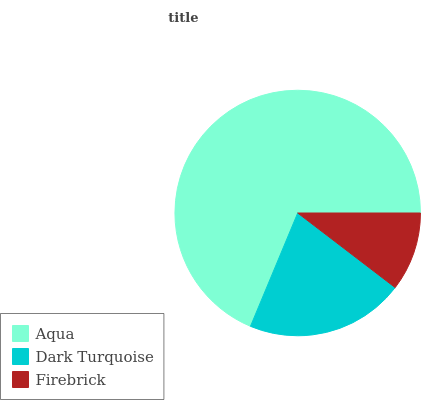Is Firebrick the minimum?
Answer yes or no. Yes. Is Aqua the maximum?
Answer yes or no. Yes. Is Dark Turquoise the minimum?
Answer yes or no. No. Is Dark Turquoise the maximum?
Answer yes or no. No. Is Aqua greater than Dark Turquoise?
Answer yes or no. Yes. Is Dark Turquoise less than Aqua?
Answer yes or no. Yes. Is Dark Turquoise greater than Aqua?
Answer yes or no. No. Is Aqua less than Dark Turquoise?
Answer yes or no. No. Is Dark Turquoise the high median?
Answer yes or no. Yes. Is Dark Turquoise the low median?
Answer yes or no. Yes. Is Aqua the high median?
Answer yes or no. No. Is Firebrick the low median?
Answer yes or no. No. 